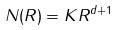Convert formula to latex. <formula><loc_0><loc_0><loc_500><loc_500>N ( R ) = K R ^ { d + 1 }</formula> 